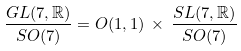<formula> <loc_0><loc_0><loc_500><loc_500>\frac { G L ( 7 , \mathbb { R } ) } { S O ( 7 ) } = O ( 1 , 1 ) \, \times \, \frac { S L ( 7 , \mathbb { R } ) } { S O ( 7 ) }</formula> 